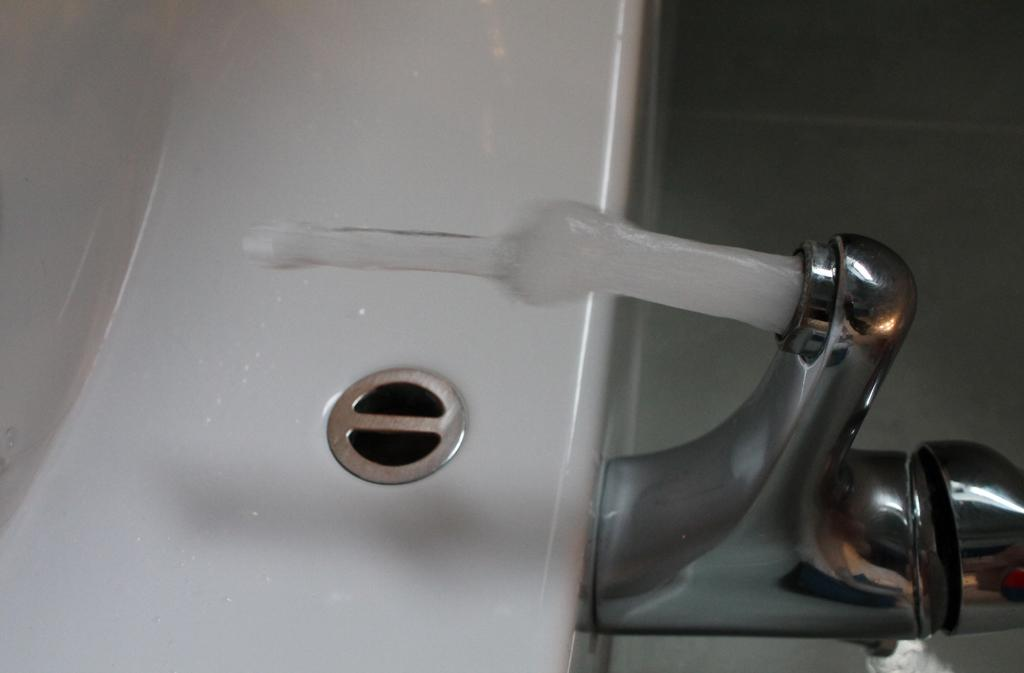What can be seen on the right side of the image? There is a stainless tap on the right side of the image. What is the tap doing in the image? Water is flowing from the tap. What is located in the middle of the image? There is a sink in the middle of the image. What type of toothbrush is being used with the unit in the image? There is no toothbrush or unit present in the image. 